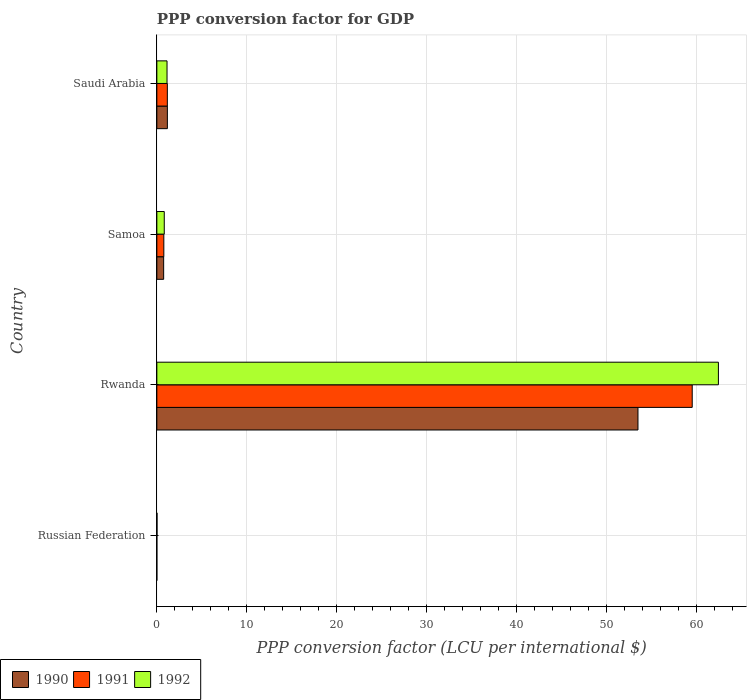How many groups of bars are there?
Offer a very short reply. 4. Are the number of bars per tick equal to the number of legend labels?
Ensure brevity in your answer.  Yes. What is the label of the 3rd group of bars from the top?
Provide a short and direct response. Rwanda. In how many cases, is the number of bars for a given country not equal to the number of legend labels?
Offer a very short reply. 0. What is the PPP conversion factor for GDP in 1990 in Saudi Arabia?
Ensure brevity in your answer.  1.17. Across all countries, what is the maximum PPP conversion factor for GDP in 1992?
Offer a very short reply. 62.44. Across all countries, what is the minimum PPP conversion factor for GDP in 1991?
Your response must be concise. 0. In which country was the PPP conversion factor for GDP in 1990 maximum?
Give a very brief answer. Rwanda. In which country was the PPP conversion factor for GDP in 1990 minimum?
Ensure brevity in your answer.  Russian Federation. What is the total PPP conversion factor for GDP in 1990 in the graph?
Keep it short and to the point. 55.42. What is the difference between the PPP conversion factor for GDP in 1992 in Russian Federation and that in Saudi Arabia?
Provide a short and direct response. -1.11. What is the difference between the PPP conversion factor for GDP in 1990 in Russian Federation and the PPP conversion factor for GDP in 1991 in Rwanda?
Your answer should be very brief. -59.53. What is the average PPP conversion factor for GDP in 1991 per country?
Your answer should be compact. 15.37. What is the difference between the PPP conversion factor for GDP in 1992 and PPP conversion factor for GDP in 1990 in Rwanda?
Offer a very short reply. 8.94. In how many countries, is the PPP conversion factor for GDP in 1992 greater than 56 LCU?
Keep it short and to the point. 1. What is the ratio of the PPP conversion factor for GDP in 1990 in Samoa to that in Saudi Arabia?
Ensure brevity in your answer.  0.65. Is the PPP conversion factor for GDP in 1992 in Russian Federation less than that in Saudi Arabia?
Your answer should be compact. Yes. Is the difference between the PPP conversion factor for GDP in 1992 in Samoa and Saudi Arabia greater than the difference between the PPP conversion factor for GDP in 1990 in Samoa and Saudi Arabia?
Give a very brief answer. Yes. What is the difference between the highest and the second highest PPP conversion factor for GDP in 1991?
Your response must be concise. 58.36. What is the difference between the highest and the lowest PPP conversion factor for GDP in 1990?
Offer a terse response. 53.5. In how many countries, is the PPP conversion factor for GDP in 1991 greater than the average PPP conversion factor for GDP in 1991 taken over all countries?
Ensure brevity in your answer.  1. What does the 3rd bar from the bottom in Rwanda represents?
Give a very brief answer. 1992. How many countries are there in the graph?
Provide a succinct answer. 4. Does the graph contain any zero values?
Your response must be concise. No. Where does the legend appear in the graph?
Keep it short and to the point. Bottom left. How many legend labels are there?
Give a very brief answer. 3. How are the legend labels stacked?
Your response must be concise. Horizontal. What is the title of the graph?
Make the answer very short. PPP conversion factor for GDP. What is the label or title of the X-axis?
Give a very brief answer. PPP conversion factor (LCU per international $). What is the label or title of the Y-axis?
Ensure brevity in your answer.  Country. What is the PPP conversion factor (LCU per international $) of 1990 in Russian Federation?
Your answer should be compact. 0. What is the PPP conversion factor (LCU per international $) in 1991 in Russian Federation?
Your response must be concise. 0. What is the PPP conversion factor (LCU per international $) of 1992 in Russian Federation?
Keep it short and to the point. 0.02. What is the PPP conversion factor (LCU per international $) in 1990 in Rwanda?
Your answer should be very brief. 53.5. What is the PPP conversion factor (LCU per international $) in 1991 in Rwanda?
Keep it short and to the point. 59.53. What is the PPP conversion factor (LCU per international $) in 1992 in Rwanda?
Keep it short and to the point. 62.44. What is the PPP conversion factor (LCU per international $) of 1990 in Samoa?
Make the answer very short. 0.76. What is the PPP conversion factor (LCU per international $) in 1991 in Samoa?
Your answer should be compact. 0.78. What is the PPP conversion factor (LCU per international $) in 1992 in Samoa?
Keep it short and to the point. 0.82. What is the PPP conversion factor (LCU per international $) in 1990 in Saudi Arabia?
Keep it short and to the point. 1.17. What is the PPP conversion factor (LCU per international $) in 1991 in Saudi Arabia?
Your response must be concise. 1.17. What is the PPP conversion factor (LCU per international $) in 1992 in Saudi Arabia?
Provide a short and direct response. 1.13. Across all countries, what is the maximum PPP conversion factor (LCU per international $) of 1990?
Make the answer very short. 53.5. Across all countries, what is the maximum PPP conversion factor (LCU per international $) of 1991?
Keep it short and to the point. 59.53. Across all countries, what is the maximum PPP conversion factor (LCU per international $) of 1992?
Give a very brief answer. 62.44. Across all countries, what is the minimum PPP conversion factor (LCU per international $) of 1990?
Give a very brief answer. 0. Across all countries, what is the minimum PPP conversion factor (LCU per international $) in 1991?
Offer a very short reply. 0. Across all countries, what is the minimum PPP conversion factor (LCU per international $) in 1992?
Your answer should be compact. 0.02. What is the total PPP conversion factor (LCU per international $) of 1990 in the graph?
Your answer should be compact. 55.42. What is the total PPP conversion factor (LCU per international $) of 1991 in the graph?
Keep it short and to the point. 61.47. What is the total PPP conversion factor (LCU per international $) in 1992 in the graph?
Your answer should be very brief. 64.42. What is the difference between the PPP conversion factor (LCU per international $) in 1990 in Russian Federation and that in Rwanda?
Give a very brief answer. -53.5. What is the difference between the PPP conversion factor (LCU per international $) in 1991 in Russian Federation and that in Rwanda?
Keep it short and to the point. -59.53. What is the difference between the PPP conversion factor (LCU per international $) in 1992 in Russian Federation and that in Rwanda?
Keep it short and to the point. -62.42. What is the difference between the PPP conversion factor (LCU per international $) in 1990 in Russian Federation and that in Samoa?
Provide a succinct answer. -0.76. What is the difference between the PPP conversion factor (LCU per international $) in 1991 in Russian Federation and that in Samoa?
Keep it short and to the point. -0.78. What is the difference between the PPP conversion factor (LCU per international $) of 1992 in Russian Federation and that in Samoa?
Give a very brief answer. -0.81. What is the difference between the PPP conversion factor (LCU per international $) of 1990 in Russian Federation and that in Saudi Arabia?
Ensure brevity in your answer.  -1.17. What is the difference between the PPP conversion factor (LCU per international $) of 1991 in Russian Federation and that in Saudi Arabia?
Keep it short and to the point. -1.17. What is the difference between the PPP conversion factor (LCU per international $) in 1992 in Russian Federation and that in Saudi Arabia?
Offer a terse response. -1.11. What is the difference between the PPP conversion factor (LCU per international $) of 1990 in Rwanda and that in Samoa?
Offer a terse response. 52.74. What is the difference between the PPP conversion factor (LCU per international $) in 1991 in Rwanda and that in Samoa?
Provide a succinct answer. 58.75. What is the difference between the PPP conversion factor (LCU per international $) in 1992 in Rwanda and that in Samoa?
Offer a very short reply. 61.62. What is the difference between the PPP conversion factor (LCU per international $) in 1990 in Rwanda and that in Saudi Arabia?
Your answer should be very brief. 52.33. What is the difference between the PPP conversion factor (LCU per international $) of 1991 in Rwanda and that in Saudi Arabia?
Give a very brief answer. 58.36. What is the difference between the PPP conversion factor (LCU per international $) in 1992 in Rwanda and that in Saudi Arabia?
Ensure brevity in your answer.  61.31. What is the difference between the PPP conversion factor (LCU per international $) in 1990 in Samoa and that in Saudi Arabia?
Ensure brevity in your answer.  -0.41. What is the difference between the PPP conversion factor (LCU per international $) of 1991 in Samoa and that in Saudi Arabia?
Ensure brevity in your answer.  -0.39. What is the difference between the PPP conversion factor (LCU per international $) in 1992 in Samoa and that in Saudi Arabia?
Offer a very short reply. -0.31. What is the difference between the PPP conversion factor (LCU per international $) in 1990 in Russian Federation and the PPP conversion factor (LCU per international $) in 1991 in Rwanda?
Offer a terse response. -59.53. What is the difference between the PPP conversion factor (LCU per international $) in 1990 in Russian Federation and the PPP conversion factor (LCU per international $) in 1992 in Rwanda?
Your answer should be compact. -62.44. What is the difference between the PPP conversion factor (LCU per international $) in 1991 in Russian Federation and the PPP conversion factor (LCU per international $) in 1992 in Rwanda?
Your response must be concise. -62.44. What is the difference between the PPP conversion factor (LCU per international $) of 1990 in Russian Federation and the PPP conversion factor (LCU per international $) of 1991 in Samoa?
Make the answer very short. -0.78. What is the difference between the PPP conversion factor (LCU per international $) of 1990 in Russian Federation and the PPP conversion factor (LCU per international $) of 1992 in Samoa?
Ensure brevity in your answer.  -0.82. What is the difference between the PPP conversion factor (LCU per international $) of 1991 in Russian Federation and the PPP conversion factor (LCU per international $) of 1992 in Samoa?
Ensure brevity in your answer.  -0.82. What is the difference between the PPP conversion factor (LCU per international $) of 1990 in Russian Federation and the PPP conversion factor (LCU per international $) of 1991 in Saudi Arabia?
Provide a succinct answer. -1.17. What is the difference between the PPP conversion factor (LCU per international $) of 1990 in Russian Federation and the PPP conversion factor (LCU per international $) of 1992 in Saudi Arabia?
Provide a succinct answer. -1.13. What is the difference between the PPP conversion factor (LCU per international $) in 1991 in Russian Federation and the PPP conversion factor (LCU per international $) in 1992 in Saudi Arabia?
Ensure brevity in your answer.  -1.13. What is the difference between the PPP conversion factor (LCU per international $) of 1990 in Rwanda and the PPP conversion factor (LCU per international $) of 1991 in Samoa?
Your answer should be very brief. 52.72. What is the difference between the PPP conversion factor (LCU per international $) in 1990 in Rwanda and the PPP conversion factor (LCU per international $) in 1992 in Samoa?
Offer a very short reply. 52.67. What is the difference between the PPP conversion factor (LCU per international $) in 1991 in Rwanda and the PPP conversion factor (LCU per international $) in 1992 in Samoa?
Offer a terse response. 58.71. What is the difference between the PPP conversion factor (LCU per international $) of 1990 in Rwanda and the PPP conversion factor (LCU per international $) of 1991 in Saudi Arabia?
Your response must be concise. 52.33. What is the difference between the PPP conversion factor (LCU per international $) in 1990 in Rwanda and the PPP conversion factor (LCU per international $) in 1992 in Saudi Arabia?
Give a very brief answer. 52.37. What is the difference between the PPP conversion factor (LCU per international $) of 1991 in Rwanda and the PPP conversion factor (LCU per international $) of 1992 in Saudi Arabia?
Offer a very short reply. 58.4. What is the difference between the PPP conversion factor (LCU per international $) of 1990 in Samoa and the PPP conversion factor (LCU per international $) of 1991 in Saudi Arabia?
Make the answer very short. -0.41. What is the difference between the PPP conversion factor (LCU per international $) of 1990 in Samoa and the PPP conversion factor (LCU per international $) of 1992 in Saudi Arabia?
Your answer should be very brief. -0.38. What is the difference between the PPP conversion factor (LCU per international $) of 1991 in Samoa and the PPP conversion factor (LCU per international $) of 1992 in Saudi Arabia?
Provide a short and direct response. -0.36. What is the average PPP conversion factor (LCU per international $) of 1990 per country?
Give a very brief answer. 13.86. What is the average PPP conversion factor (LCU per international $) of 1991 per country?
Your answer should be compact. 15.37. What is the average PPP conversion factor (LCU per international $) in 1992 per country?
Make the answer very short. 16.1. What is the difference between the PPP conversion factor (LCU per international $) of 1990 and PPP conversion factor (LCU per international $) of 1991 in Russian Federation?
Provide a succinct answer. -0. What is the difference between the PPP conversion factor (LCU per international $) in 1990 and PPP conversion factor (LCU per international $) in 1992 in Russian Federation?
Provide a succinct answer. -0.02. What is the difference between the PPP conversion factor (LCU per international $) in 1991 and PPP conversion factor (LCU per international $) in 1992 in Russian Federation?
Provide a succinct answer. -0.02. What is the difference between the PPP conversion factor (LCU per international $) of 1990 and PPP conversion factor (LCU per international $) of 1991 in Rwanda?
Provide a succinct answer. -6.03. What is the difference between the PPP conversion factor (LCU per international $) of 1990 and PPP conversion factor (LCU per international $) of 1992 in Rwanda?
Your answer should be compact. -8.94. What is the difference between the PPP conversion factor (LCU per international $) in 1991 and PPP conversion factor (LCU per international $) in 1992 in Rwanda?
Offer a very short reply. -2.91. What is the difference between the PPP conversion factor (LCU per international $) of 1990 and PPP conversion factor (LCU per international $) of 1991 in Samoa?
Keep it short and to the point. -0.02. What is the difference between the PPP conversion factor (LCU per international $) of 1990 and PPP conversion factor (LCU per international $) of 1992 in Samoa?
Your response must be concise. -0.07. What is the difference between the PPP conversion factor (LCU per international $) of 1991 and PPP conversion factor (LCU per international $) of 1992 in Samoa?
Your answer should be compact. -0.05. What is the difference between the PPP conversion factor (LCU per international $) in 1990 and PPP conversion factor (LCU per international $) in 1991 in Saudi Arabia?
Make the answer very short. 0. What is the difference between the PPP conversion factor (LCU per international $) of 1990 and PPP conversion factor (LCU per international $) of 1992 in Saudi Arabia?
Your answer should be compact. 0.04. What is the difference between the PPP conversion factor (LCU per international $) in 1991 and PPP conversion factor (LCU per international $) in 1992 in Saudi Arabia?
Offer a terse response. 0.04. What is the ratio of the PPP conversion factor (LCU per international $) in 1992 in Russian Federation to that in Rwanda?
Your answer should be compact. 0. What is the ratio of the PPP conversion factor (LCU per international $) of 1990 in Russian Federation to that in Samoa?
Give a very brief answer. 0. What is the ratio of the PPP conversion factor (LCU per international $) of 1991 in Russian Federation to that in Samoa?
Your answer should be very brief. 0. What is the ratio of the PPP conversion factor (LCU per international $) of 1992 in Russian Federation to that in Samoa?
Your answer should be very brief. 0.02. What is the ratio of the PPP conversion factor (LCU per international $) of 1990 in Russian Federation to that in Saudi Arabia?
Your answer should be very brief. 0. What is the ratio of the PPP conversion factor (LCU per international $) in 1992 in Russian Federation to that in Saudi Arabia?
Keep it short and to the point. 0.02. What is the ratio of the PPP conversion factor (LCU per international $) in 1990 in Rwanda to that in Samoa?
Your answer should be compact. 70.74. What is the ratio of the PPP conversion factor (LCU per international $) in 1991 in Rwanda to that in Samoa?
Offer a very short reply. 76.65. What is the ratio of the PPP conversion factor (LCU per international $) in 1992 in Rwanda to that in Samoa?
Provide a short and direct response. 75.74. What is the ratio of the PPP conversion factor (LCU per international $) in 1990 in Rwanda to that in Saudi Arabia?
Provide a succinct answer. 45.72. What is the ratio of the PPP conversion factor (LCU per international $) of 1991 in Rwanda to that in Saudi Arabia?
Your answer should be very brief. 51. What is the ratio of the PPP conversion factor (LCU per international $) of 1992 in Rwanda to that in Saudi Arabia?
Keep it short and to the point. 55.16. What is the ratio of the PPP conversion factor (LCU per international $) of 1990 in Samoa to that in Saudi Arabia?
Ensure brevity in your answer.  0.65. What is the ratio of the PPP conversion factor (LCU per international $) of 1991 in Samoa to that in Saudi Arabia?
Keep it short and to the point. 0.67. What is the ratio of the PPP conversion factor (LCU per international $) of 1992 in Samoa to that in Saudi Arabia?
Offer a terse response. 0.73. What is the difference between the highest and the second highest PPP conversion factor (LCU per international $) of 1990?
Your answer should be very brief. 52.33. What is the difference between the highest and the second highest PPP conversion factor (LCU per international $) of 1991?
Your answer should be compact. 58.36. What is the difference between the highest and the second highest PPP conversion factor (LCU per international $) in 1992?
Your answer should be very brief. 61.31. What is the difference between the highest and the lowest PPP conversion factor (LCU per international $) in 1990?
Your response must be concise. 53.5. What is the difference between the highest and the lowest PPP conversion factor (LCU per international $) of 1991?
Offer a very short reply. 59.53. What is the difference between the highest and the lowest PPP conversion factor (LCU per international $) in 1992?
Make the answer very short. 62.42. 